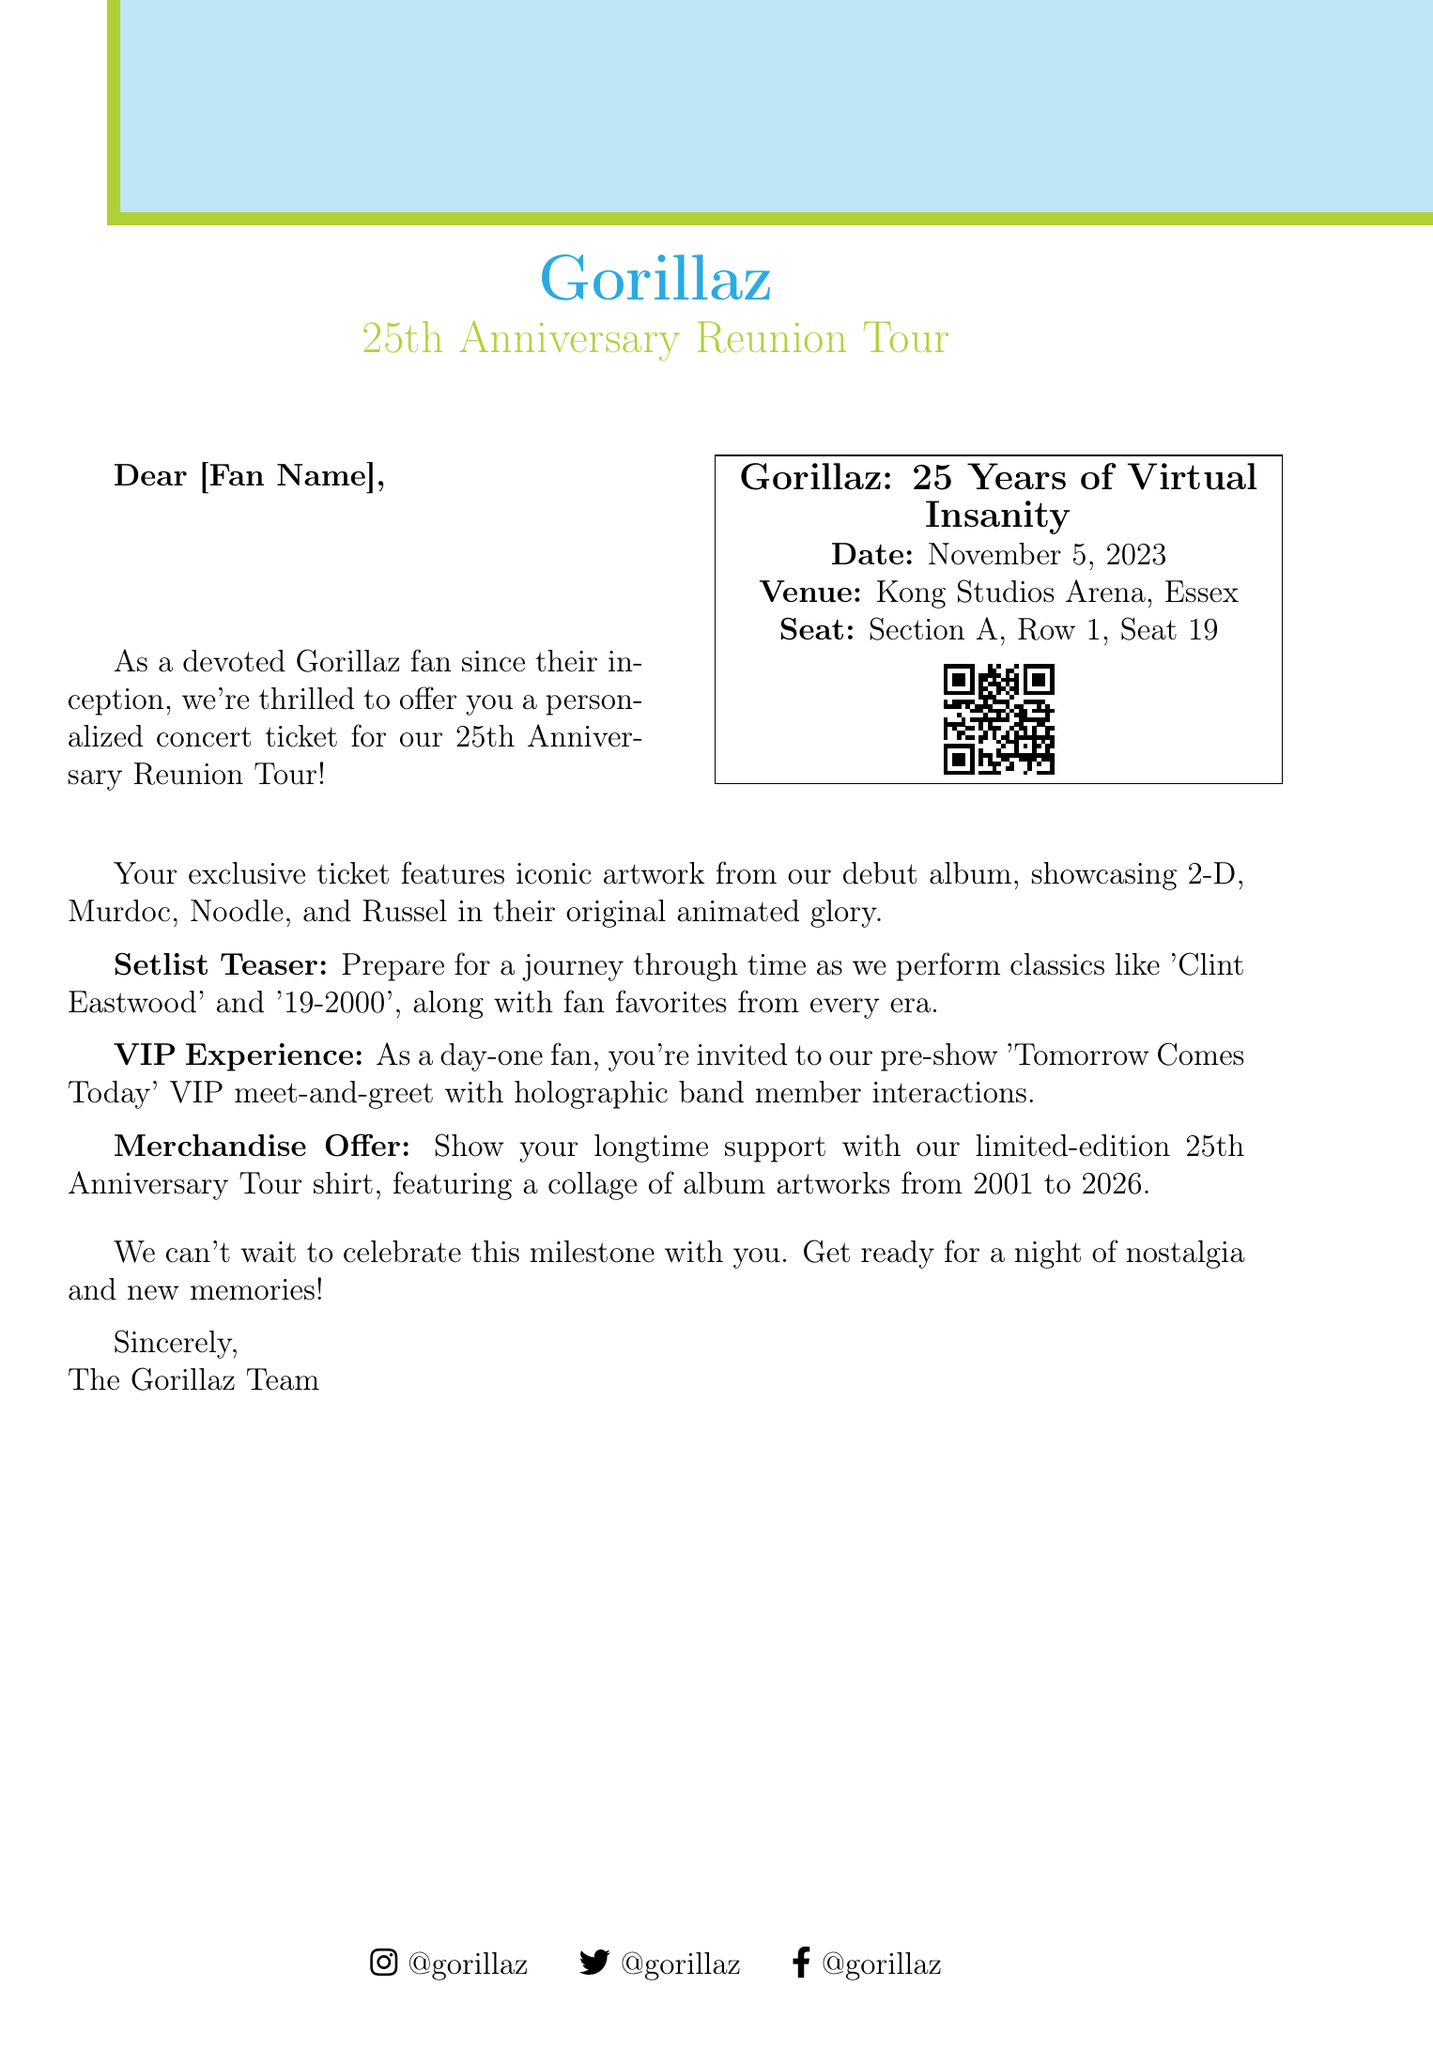What is the event name? The event name is stated in the ticket details section of the document.
Answer: Gorillaz: 25 Years of Virtual Insanity What date is the concert? The date of the concert is explicitly mentioned in the ticket details.
Answer: November 5, 2023 Where is the concert taking place? The venue for the concert is specified in the ticket details section.
Answer: Kong Studios Arena, Essex What is featured on the exclusive ticket? The artwork description describes what is featured on the ticket.
Answer: Iconic artwork from our debut album What special experience is offered for day-one fans? The document mentions a specific experience for day-one fans in the VIP experience section.
Answer: Pre-show 'Tomorrow Comes Today' VIP meet-and-greet What classics will be performed during the concert? The setlist teaser mentions two specific songs that will be performed.
Answer: Clint Eastwood and 19-2000 How many years of the Gorillaz are being celebrated? The event celebrates a significant milestone that is directly stated.
Answer: 25 years What merchandise is offered for the anniversary? The merchandise offer section specifically details what type of merchandise is available.
Answer: Limited-edition 25th Anniversary Tour shirt Who signed off the document? The closing section indicates who wrote the message.
Answer: The Gorillaz Team 